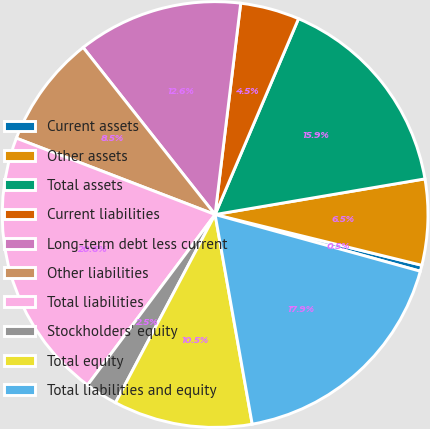Convert chart to OTSL. <chart><loc_0><loc_0><loc_500><loc_500><pie_chart><fcel>Current assets<fcel>Other assets<fcel>Total assets<fcel>Current liabilities<fcel>Long-term debt less current<fcel>Other liabilities<fcel>Total liabilities<fcel>Stockholders' equity<fcel>Total equity<fcel>Total liabilities and equity<nl><fcel>0.46%<fcel>6.51%<fcel>15.91%<fcel>4.49%<fcel>12.56%<fcel>8.52%<fcel>20.62%<fcel>2.47%<fcel>10.54%<fcel>17.92%<nl></chart> 